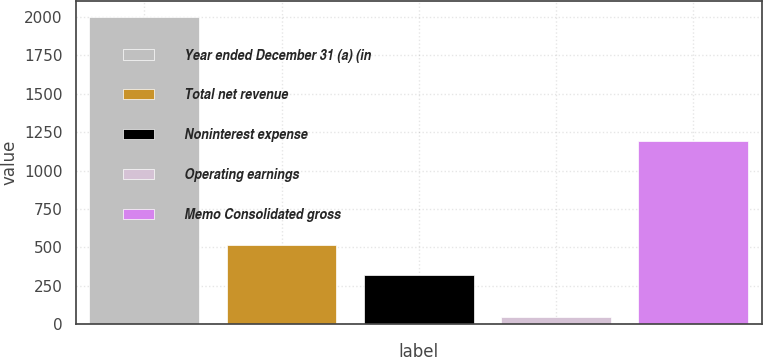<chart> <loc_0><loc_0><loc_500><loc_500><bar_chart><fcel>Year ended December 31 (a) (in<fcel>Total net revenue<fcel>Noninterest expense<fcel>Operating earnings<fcel>Memo Consolidated gross<nl><fcel>2004<fcel>512.6<fcel>317<fcel>48<fcel>1191<nl></chart> 